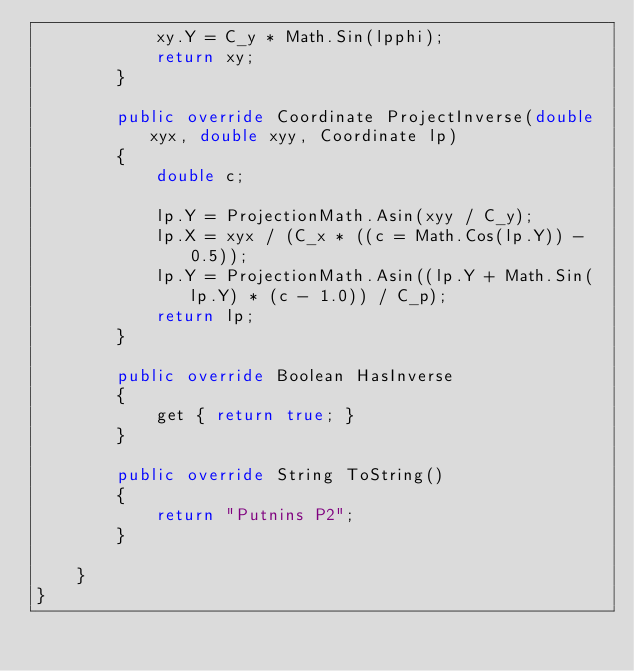Convert code to text. <code><loc_0><loc_0><loc_500><loc_500><_C#_>            xy.Y = C_y * Math.Sin(lpphi);
            return xy;
        }

        public override Coordinate ProjectInverse(double xyx, double xyy, Coordinate lp)
        {
            double c;

            lp.Y = ProjectionMath.Asin(xyy / C_y);
            lp.X = xyx / (C_x * ((c = Math.Cos(lp.Y)) - 0.5));
            lp.Y = ProjectionMath.Asin((lp.Y + Math.Sin(lp.Y) * (c - 1.0)) / C_p);
            return lp;
        }

        public override Boolean HasInverse
        {
            get { return true; }
        }

        public override String ToString()
        {
            return "Putnins P2";
        }

    }
}</code> 